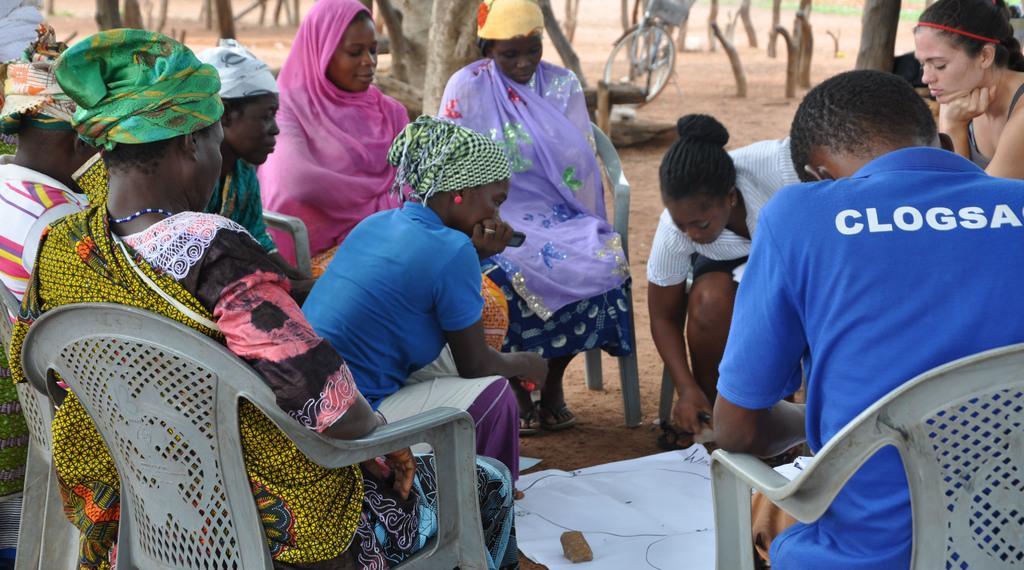Please provide a concise description of this image. In this image I can see group of people sitting on the chairs at the middle there is a chart paper, behind them there are so many trees and bicycle. 